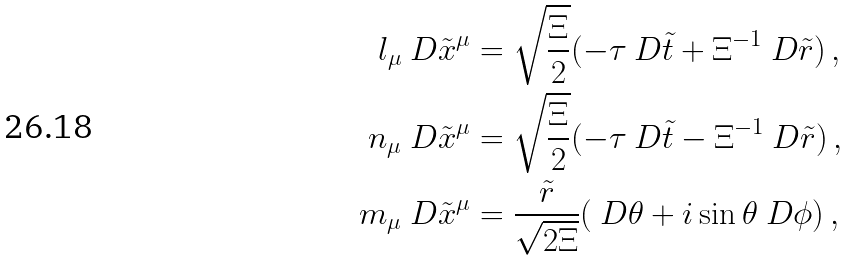Convert formula to latex. <formula><loc_0><loc_0><loc_500><loc_500>l _ { \mu } \ D \tilde { x } ^ { \mu } & = \sqrt { \frac { \Xi } { 2 } } ( - \tau \ D \tilde { t } + \Xi ^ { - 1 } \ D \tilde { r } ) \, , \\ n _ { \mu } \ D \tilde { x } ^ { \mu } & = \sqrt { \frac { \Xi } { 2 } } ( - \tau \ D \tilde { t } - \Xi ^ { - 1 } \ D \tilde { r } ) \, , \\ m _ { \mu } \ D \tilde { x } ^ { \mu } & = \frac { \tilde { r } } { \sqrt { 2 \Xi } } ( \ D \theta + i \sin \theta \ D \phi ) \, ,</formula> 